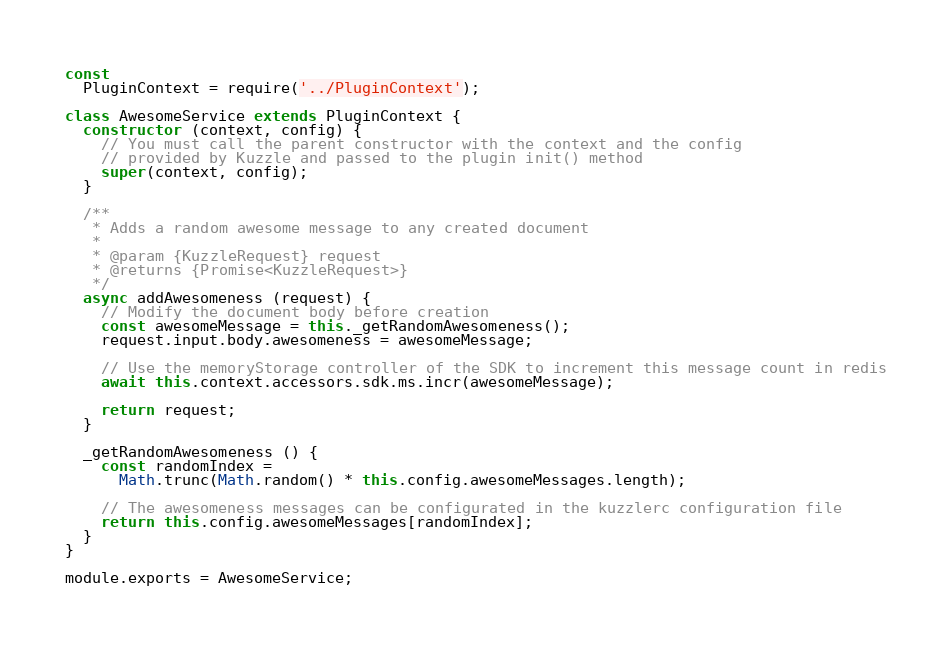<code> <loc_0><loc_0><loc_500><loc_500><_JavaScript_>
const
  PluginContext = require('../PluginContext');

class AwesomeService extends PluginContext {
  constructor (context, config) {
    // You must call the parent constructor with the context and the config
    // provided by Kuzzle and passed to the plugin init() method
    super(context, config);
  }

  /**
   * Adds a random awesome message to any created document
   *
   * @param {KuzzleRequest} request
   * @returns {Promise<KuzzleRequest>}
   */
  async addAwesomeness (request) {
    // Modify the document body before creation
    const awesomeMessage = this._getRandomAwesomeness();
    request.input.body.awesomeness = awesomeMessage;

    // Use the memoryStorage controller of the SDK to increment this message count in redis
    await this.context.accessors.sdk.ms.incr(awesomeMessage);

    return request;
  }

  _getRandomAwesomeness () {
    const randomIndex =
      Math.trunc(Math.random() * this.config.awesomeMessages.length);

    // The awesomeness messages can be configurated in the kuzzlerc configuration file
    return this.config.awesomeMessages[randomIndex];
  }
}

module.exports = AwesomeService;
</code> 